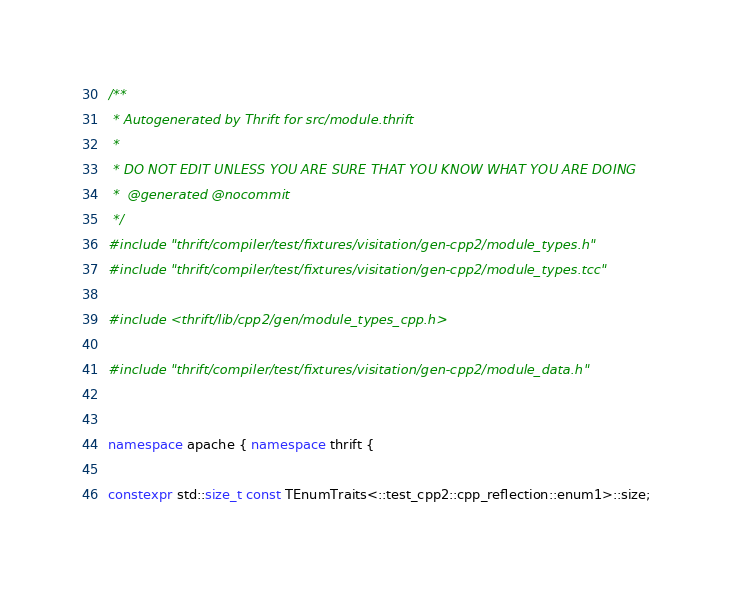Convert code to text. <code><loc_0><loc_0><loc_500><loc_500><_C++_>/**
 * Autogenerated by Thrift for src/module.thrift
 *
 * DO NOT EDIT UNLESS YOU ARE SURE THAT YOU KNOW WHAT YOU ARE DOING
 *  @generated @nocommit
 */
#include "thrift/compiler/test/fixtures/visitation/gen-cpp2/module_types.h"
#include "thrift/compiler/test/fixtures/visitation/gen-cpp2/module_types.tcc"

#include <thrift/lib/cpp2/gen/module_types_cpp.h>

#include "thrift/compiler/test/fixtures/visitation/gen-cpp2/module_data.h"


namespace apache { namespace thrift {

constexpr std::size_t const TEnumTraits<::test_cpp2::cpp_reflection::enum1>::size;</code> 